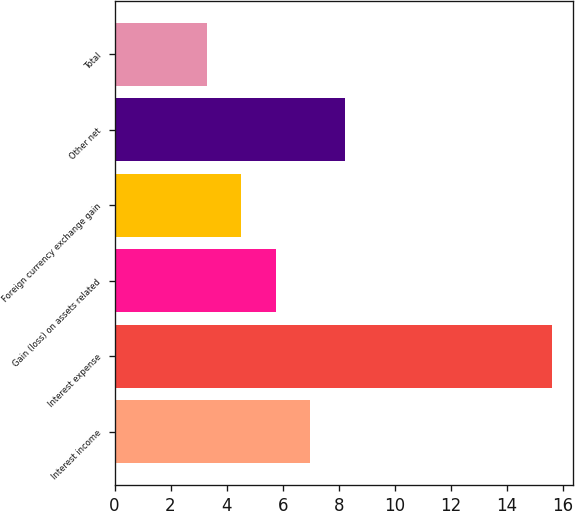Convert chart to OTSL. <chart><loc_0><loc_0><loc_500><loc_500><bar_chart><fcel>Interest income<fcel>Interest expense<fcel>Gain (loss) on assets related<fcel>Foreign currency exchange gain<fcel>Other net<fcel>Total<nl><fcel>6.99<fcel>15.6<fcel>5.76<fcel>4.53<fcel>8.22<fcel>3.3<nl></chart> 